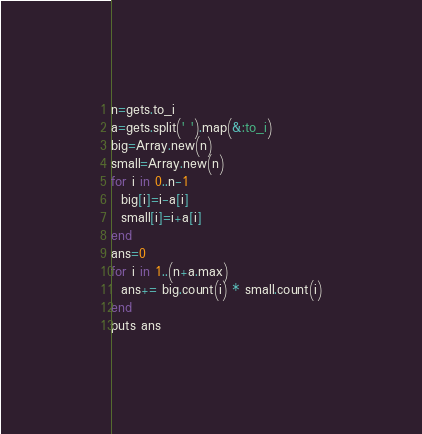Convert code to text. <code><loc_0><loc_0><loc_500><loc_500><_Ruby_>n=gets.to_i
a=gets.split(' ').map(&:to_i)
big=Array.new(n)
small=Array.new(n)
for i in 0..n-1
  big[i]=i-a[i]
  small[i]=i+a[i]
end
ans=0
for i in 1..(n+a.max)
  ans+= big.count(i) * small.count(i)
end
puts ans</code> 